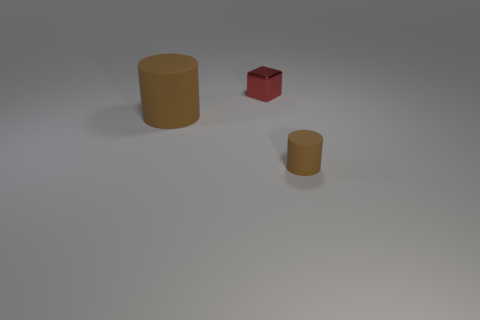Add 3 big green things. How many objects exist? 6 Subtract all cylinders. How many objects are left? 1 Subtract 0 cyan cylinders. How many objects are left? 3 Subtract all large red metallic objects. Subtract all red cubes. How many objects are left? 2 Add 1 red things. How many red things are left? 2 Add 1 big blue metal things. How many big blue metal things exist? 1 